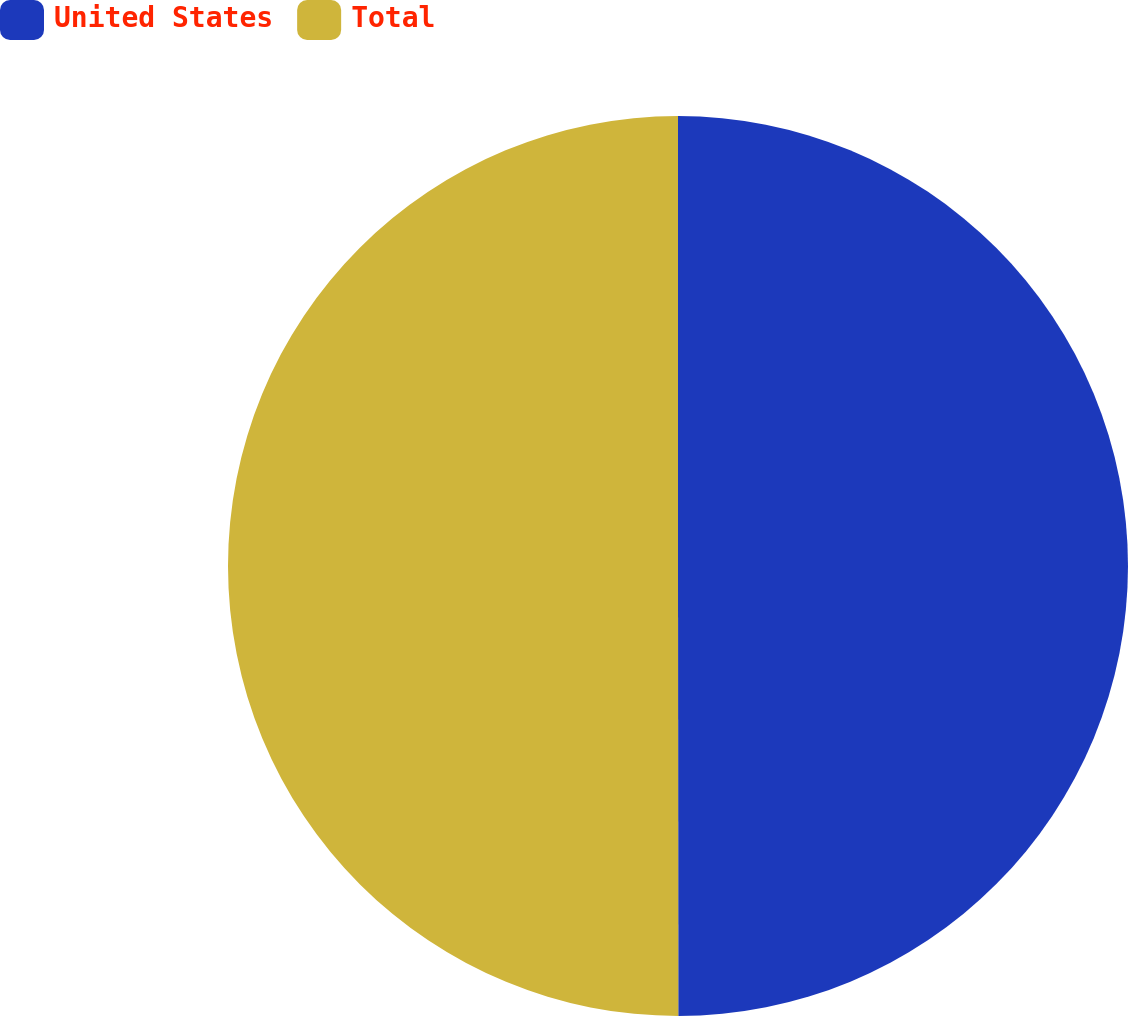Convert chart. <chart><loc_0><loc_0><loc_500><loc_500><pie_chart><fcel>United States<fcel>Total<nl><fcel>49.99%<fcel>50.01%<nl></chart> 